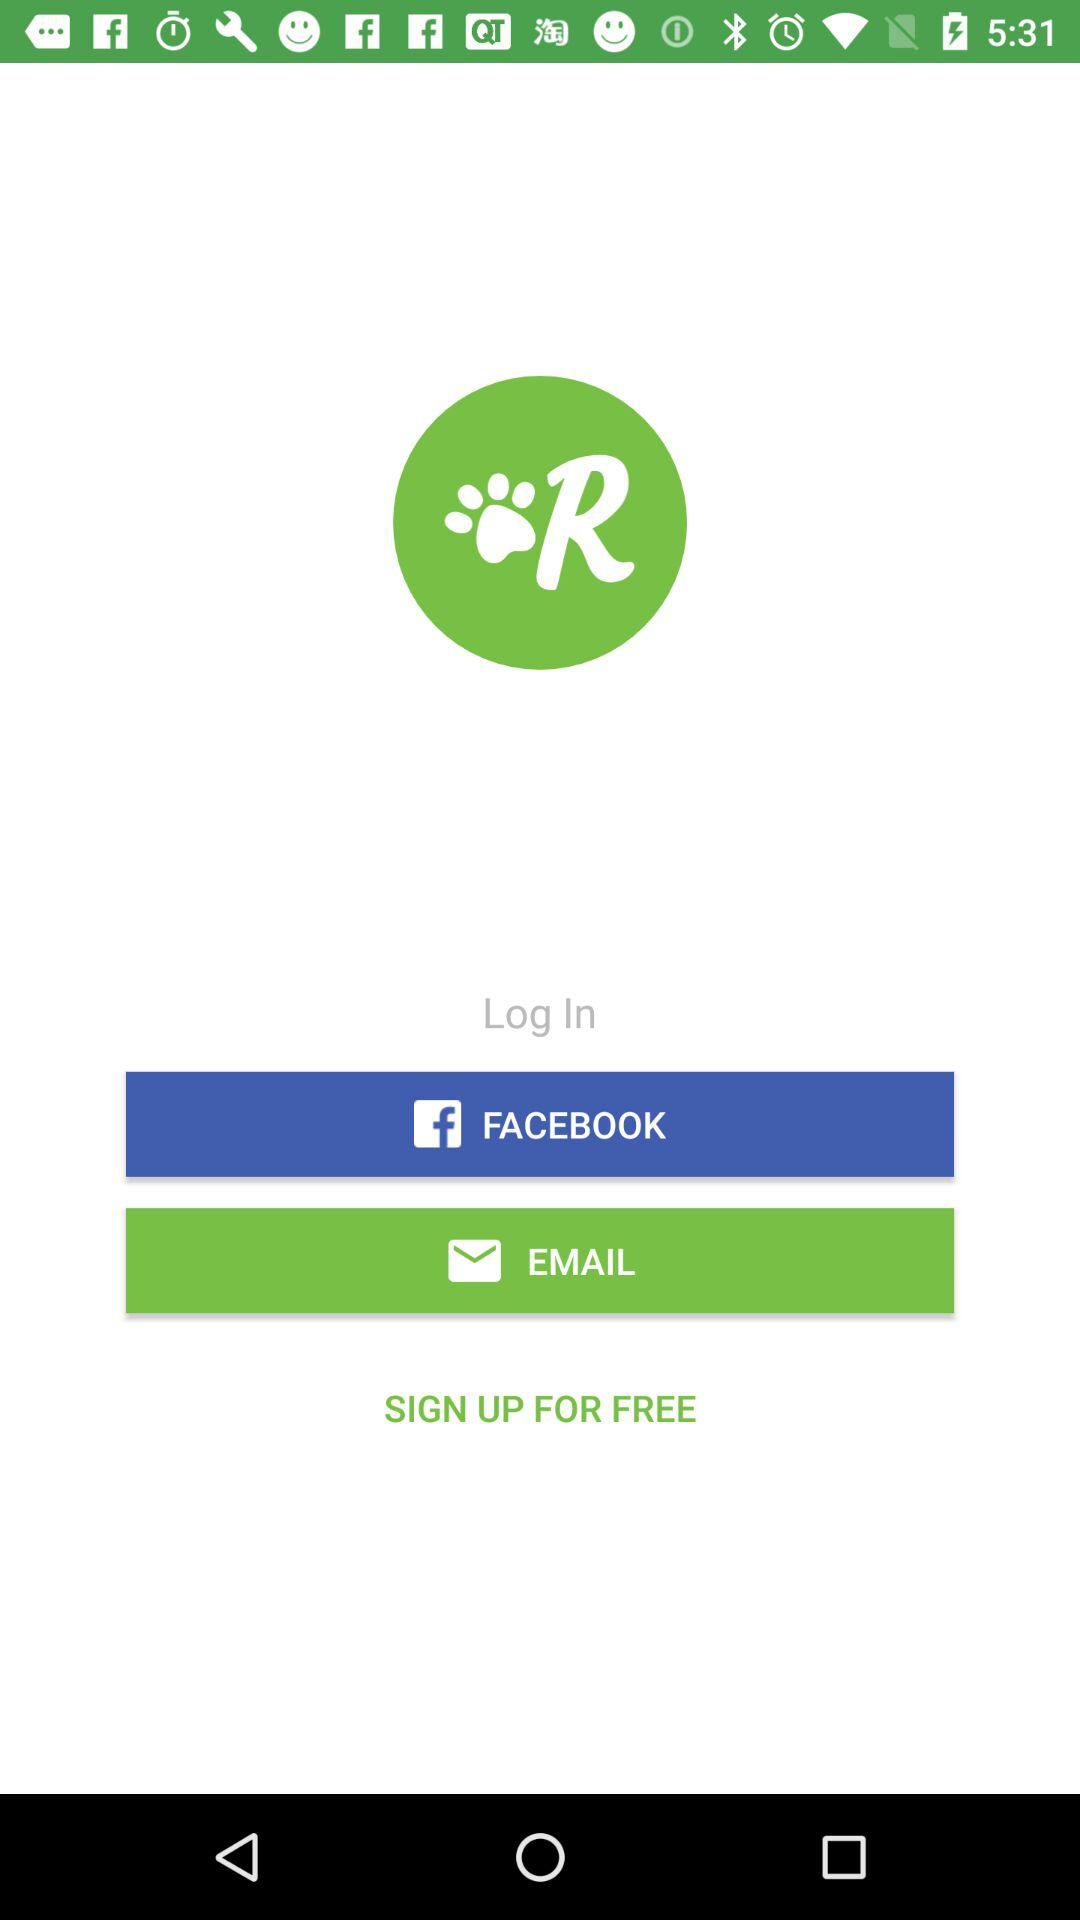How much will it cost to sign up? You can sign up for free. 